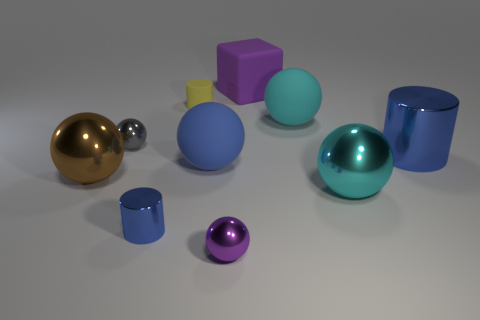Subtract 1 spheres. How many spheres are left? 5 Subtract all cyan spheres. How many spheres are left? 4 Subtract all large matte spheres. How many spheres are left? 4 Subtract all blue spheres. Subtract all purple blocks. How many spheres are left? 5 Subtract all balls. How many objects are left? 4 Add 5 tiny cylinders. How many tiny cylinders exist? 7 Subtract 0 gray cylinders. How many objects are left? 10 Subtract all tiny blue objects. Subtract all tiny blue metal blocks. How many objects are left? 9 Add 3 large blue objects. How many large blue objects are left? 5 